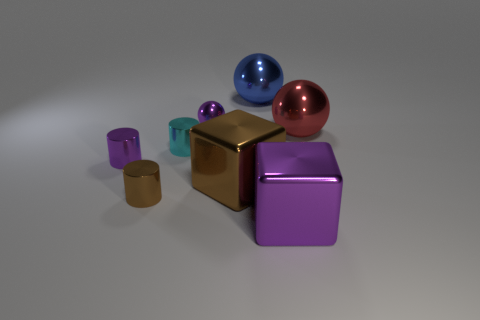Subtract all small purple cylinders. How many cylinders are left? 2 Add 2 brown objects. How many objects exist? 10 Subtract all purple cubes. How many cubes are left? 1 Subtract 1 cylinders. How many cylinders are left? 2 Subtract all spheres. How many objects are left? 5 Subtract all red cylinders. Subtract all green balls. How many cylinders are left? 3 Subtract all cyan cylinders. How many gray spheres are left? 0 Subtract all tiny purple metallic cylinders. Subtract all large metal objects. How many objects are left? 3 Add 4 metal cubes. How many metal cubes are left? 6 Add 8 purple shiny blocks. How many purple shiny blocks exist? 9 